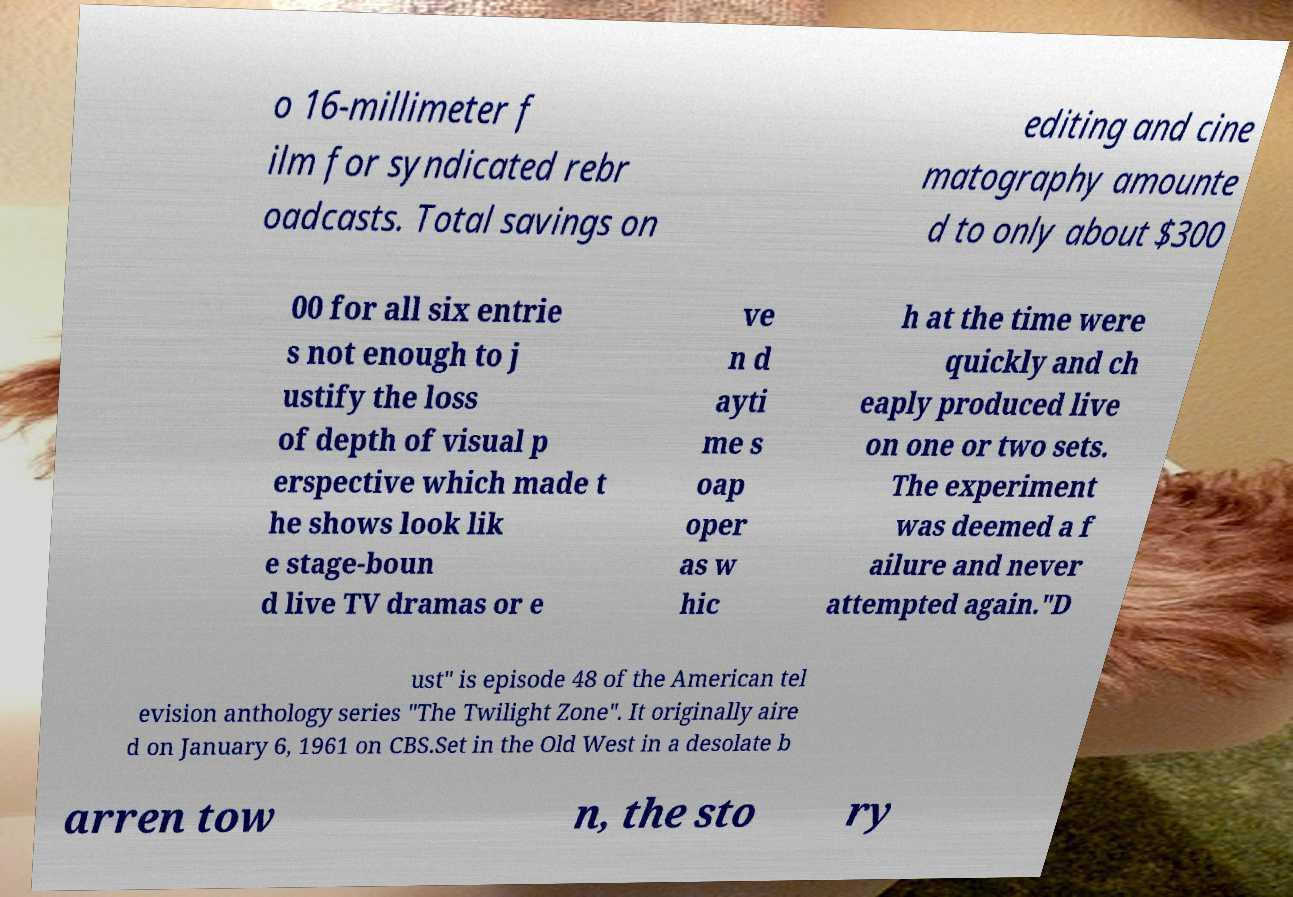What messages or text are displayed in this image? I need them in a readable, typed format. o 16-millimeter f ilm for syndicated rebr oadcasts. Total savings on editing and cine matography amounte d to only about $300 00 for all six entrie s not enough to j ustify the loss of depth of visual p erspective which made t he shows look lik e stage-boun d live TV dramas or e ve n d ayti me s oap oper as w hic h at the time were quickly and ch eaply produced live on one or two sets. The experiment was deemed a f ailure and never attempted again."D ust" is episode 48 of the American tel evision anthology series "The Twilight Zone". It originally aire d on January 6, 1961 on CBS.Set in the Old West in a desolate b arren tow n, the sto ry 